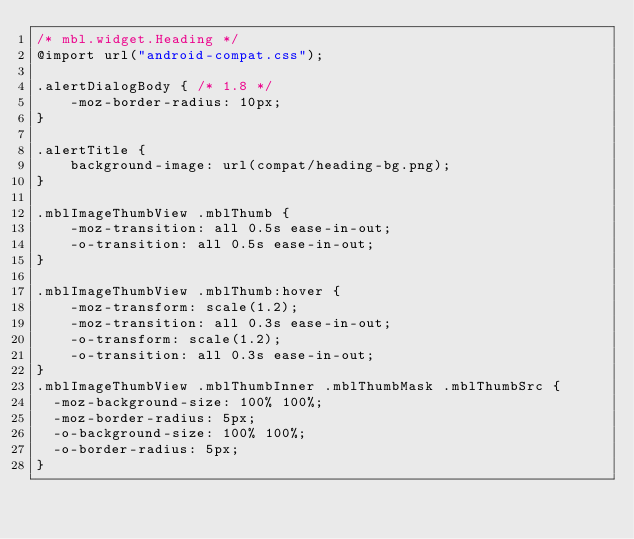Convert code to text. <code><loc_0><loc_0><loc_500><loc_500><_CSS_>/* mbl.widget.Heading */
@import url("android-compat.css");

.alertDialogBody { /* 1.8 */
	-moz-border-radius: 10px;
}

.alertTitle {
	background-image: url(compat/heading-bg.png);
}

.mblImageThumbView .mblThumb {
	-moz-transition: all 0.5s ease-in-out;
	-o-transition: all 0.5s ease-in-out;
}

.mblImageThumbView .mblThumb:hover {
	-moz-transform: scale(1.2);
	-moz-transition: all 0.3s ease-in-out;
	-o-transform: scale(1.2);
	-o-transition: all 0.3s ease-in-out;
}
.mblImageThumbView .mblThumbInner .mblThumbMask .mblThumbSrc {
  -moz-background-size: 100% 100%;
  -moz-border-radius: 5px;
  -o-background-size: 100% 100%;
  -o-border-radius: 5px;
}</code> 